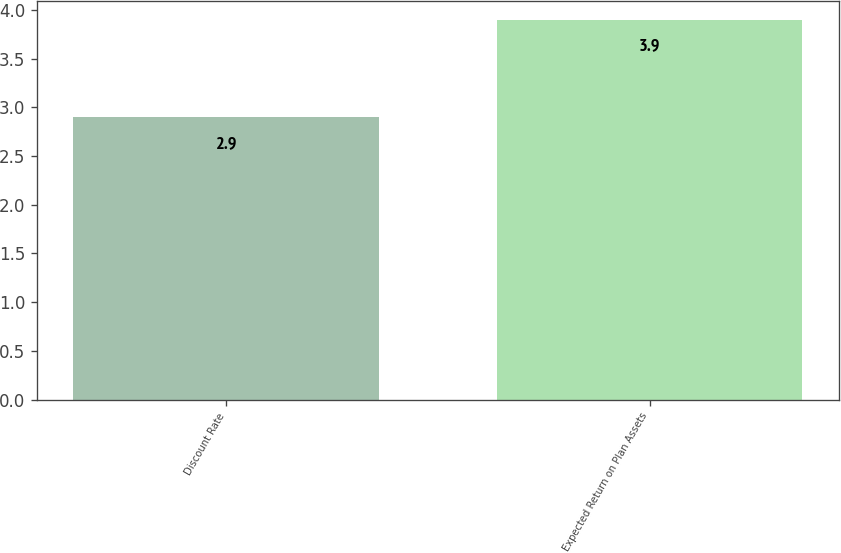Convert chart. <chart><loc_0><loc_0><loc_500><loc_500><bar_chart><fcel>Discount Rate<fcel>Expected Return on Plan Assets<nl><fcel>2.9<fcel>3.9<nl></chart> 